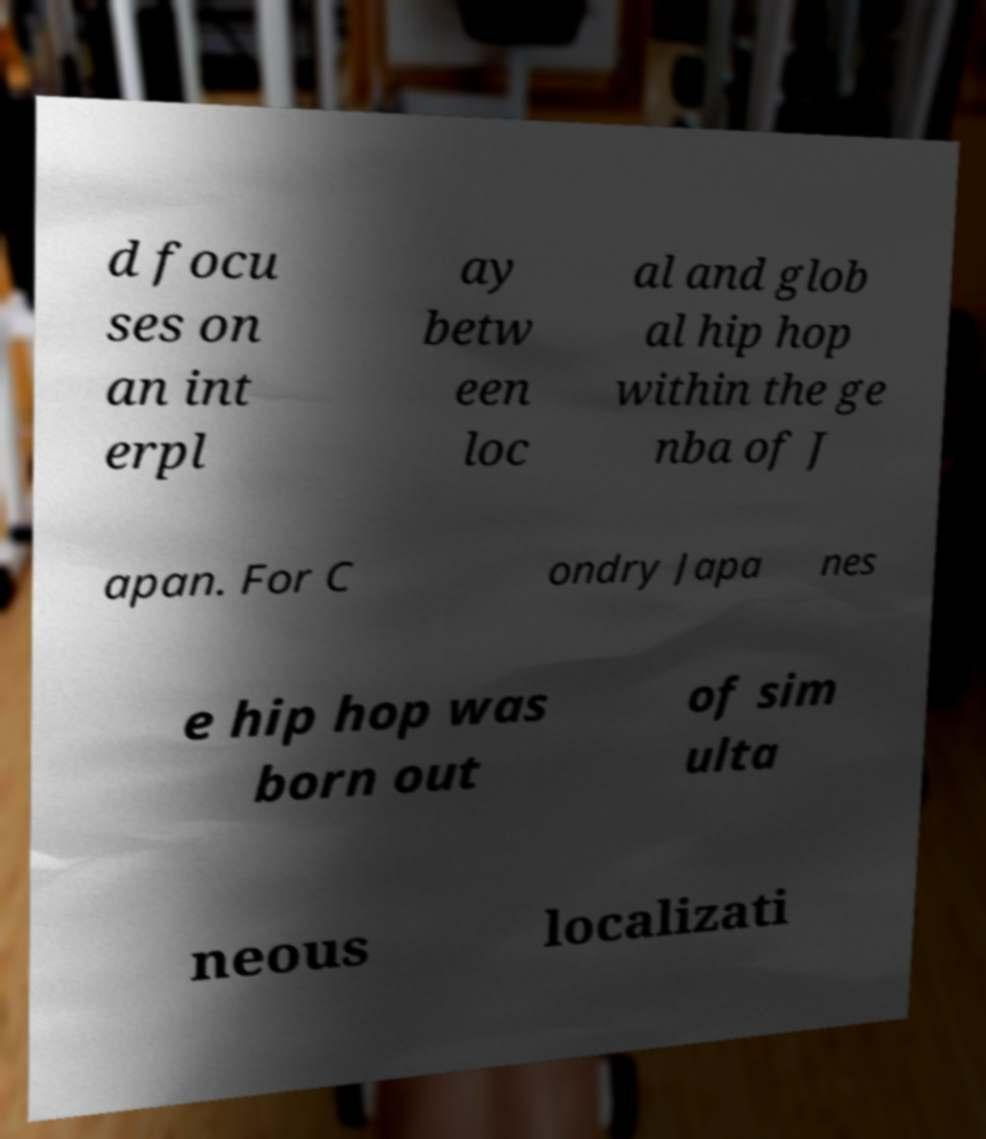I need the written content from this picture converted into text. Can you do that? d focu ses on an int erpl ay betw een loc al and glob al hip hop within the ge nba of J apan. For C ondry Japa nes e hip hop was born out of sim ulta neous localizati 